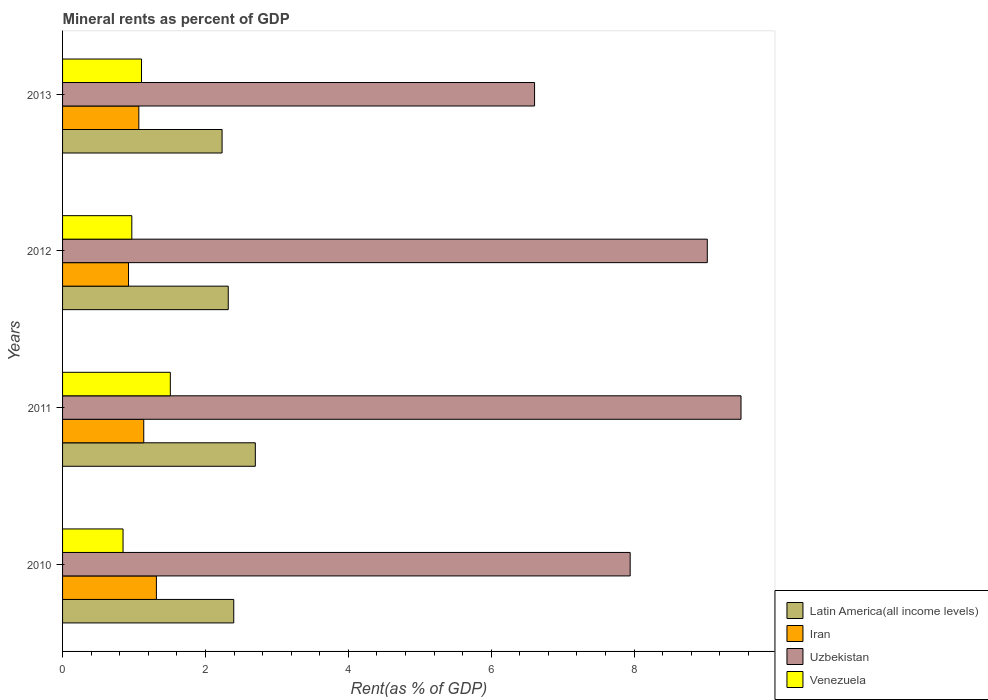In how many cases, is the number of bars for a given year not equal to the number of legend labels?
Provide a short and direct response. 0. What is the mineral rent in Latin America(all income levels) in 2010?
Offer a very short reply. 2.4. Across all years, what is the maximum mineral rent in Latin America(all income levels)?
Provide a short and direct response. 2.7. Across all years, what is the minimum mineral rent in Iran?
Your answer should be very brief. 0.92. In which year was the mineral rent in Uzbekistan maximum?
Your response must be concise. 2011. What is the total mineral rent in Latin America(all income levels) in the graph?
Provide a short and direct response. 9.65. What is the difference between the mineral rent in Uzbekistan in 2011 and that in 2012?
Provide a short and direct response. 0.47. What is the difference between the mineral rent in Iran in 2011 and the mineral rent in Latin America(all income levels) in 2012?
Give a very brief answer. -1.18. What is the average mineral rent in Uzbekistan per year?
Give a very brief answer. 8.27. In the year 2013, what is the difference between the mineral rent in Latin America(all income levels) and mineral rent in Venezuela?
Your answer should be compact. 1.13. What is the ratio of the mineral rent in Uzbekistan in 2010 to that in 2012?
Your answer should be very brief. 0.88. What is the difference between the highest and the second highest mineral rent in Iran?
Offer a very short reply. 0.18. What is the difference between the highest and the lowest mineral rent in Latin America(all income levels)?
Give a very brief answer. 0.47. Is the sum of the mineral rent in Uzbekistan in 2011 and 2013 greater than the maximum mineral rent in Latin America(all income levels) across all years?
Ensure brevity in your answer.  Yes. Is it the case that in every year, the sum of the mineral rent in Venezuela and mineral rent in Iran is greater than the sum of mineral rent in Uzbekistan and mineral rent in Latin America(all income levels)?
Provide a short and direct response. No. What does the 4th bar from the top in 2011 represents?
Your answer should be compact. Latin America(all income levels). What does the 2nd bar from the bottom in 2011 represents?
Offer a very short reply. Iran. How many bars are there?
Your answer should be very brief. 16. Are all the bars in the graph horizontal?
Your response must be concise. Yes. How are the legend labels stacked?
Keep it short and to the point. Vertical. What is the title of the graph?
Give a very brief answer. Mineral rents as percent of GDP. What is the label or title of the X-axis?
Your answer should be compact. Rent(as % of GDP). What is the label or title of the Y-axis?
Ensure brevity in your answer.  Years. What is the Rent(as % of GDP) of Latin America(all income levels) in 2010?
Your response must be concise. 2.4. What is the Rent(as % of GDP) in Iran in 2010?
Your response must be concise. 1.31. What is the Rent(as % of GDP) in Uzbekistan in 2010?
Provide a succinct answer. 7.95. What is the Rent(as % of GDP) of Venezuela in 2010?
Provide a short and direct response. 0.85. What is the Rent(as % of GDP) of Latin America(all income levels) in 2011?
Your response must be concise. 2.7. What is the Rent(as % of GDP) in Iran in 2011?
Provide a short and direct response. 1.14. What is the Rent(as % of GDP) of Uzbekistan in 2011?
Offer a very short reply. 9.5. What is the Rent(as % of GDP) in Venezuela in 2011?
Offer a very short reply. 1.51. What is the Rent(as % of GDP) of Latin America(all income levels) in 2012?
Your answer should be very brief. 2.32. What is the Rent(as % of GDP) of Iran in 2012?
Ensure brevity in your answer.  0.92. What is the Rent(as % of GDP) in Uzbekistan in 2012?
Provide a short and direct response. 9.03. What is the Rent(as % of GDP) of Venezuela in 2012?
Offer a very short reply. 0.97. What is the Rent(as % of GDP) in Latin America(all income levels) in 2013?
Keep it short and to the point. 2.23. What is the Rent(as % of GDP) of Iran in 2013?
Your response must be concise. 1.07. What is the Rent(as % of GDP) of Uzbekistan in 2013?
Your response must be concise. 6.61. What is the Rent(as % of GDP) in Venezuela in 2013?
Your answer should be compact. 1.11. Across all years, what is the maximum Rent(as % of GDP) in Latin America(all income levels)?
Your answer should be very brief. 2.7. Across all years, what is the maximum Rent(as % of GDP) in Iran?
Offer a very short reply. 1.31. Across all years, what is the maximum Rent(as % of GDP) of Uzbekistan?
Offer a very short reply. 9.5. Across all years, what is the maximum Rent(as % of GDP) of Venezuela?
Offer a very short reply. 1.51. Across all years, what is the minimum Rent(as % of GDP) in Latin America(all income levels)?
Your answer should be very brief. 2.23. Across all years, what is the minimum Rent(as % of GDP) in Iran?
Your response must be concise. 0.92. Across all years, what is the minimum Rent(as % of GDP) in Uzbekistan?
Offer a very short reply. 6.61. Across all years, what is the minimum Rent(as % of GDP) of Venezuela?
Your answer should be compact. 0.85. What is the total Rent(as % of GDP) of Latin America(all income levels) in the graph?
Your response must be concise. 9.65. What is the total Rent(as % of GDP) in Iran in the graph?
Offer a very short reply. 4.44. What is the total Rent(as % of GDP) of Uzbekistan in the graph?
Ensure brevity in your answer.  33.08. What is the total Rent(as % of GDP) in Venezuela in the graph?
Offer a very short reply. 4.43. What is the difference between the Rent(as % of GDP) of Latin America(all income levels) in 2010 and that in 2011?
Your answer should be very brief. -0.3. What is the difference between the Rent(as % of GDP) in Iran in 2010 and that in 2011?
Keep it short and to the point. 0.18. What is the difference between the Rent(as % of GDP) in Uzbekistan in 2010 and that in 2011?
Your answer should be compact. -1.55. What is the difference between the Rent(as % of GDP) in Venezuela in 2010 and that in 2011?
Your answer should be very brief. -0.66. What is the difference between the Rent(as % of GDP) of Latin America(all income levels) in 2010 and that in 2012?
Offer a terse response. 0.08. What is the difference between the Rent(as % of GDP) of Iran in 2010 and that in 2012?
Give a very brief answer. 0.39. What is the difference between the Rent(as % of GDP) of Uzbekistan in 2010 and that in 2012?
Your answer should be compact. -1.08. What is the difference between the Rent(as % of GDP) of Venezuela in 2010 and that in 2012?
Keep it short and to the point. -0.12. What is the difference between the Rent(as % of GDP) in Latin America(all income levels) in 2010 and that in 2013?
Keep it short and to the point. 0.16. What is the difference between the Rent(as % of GDP) in Iran in 2010 and that in 2013?
Your answer should be compact. 0.25. What is the difference between the Rent(as % of GDP) in Uzbekistan in 2010 and that in 2013?
Offer a terse response. 1.34. What is the difference between the Rent(as % of GDP) of Venezuela in 2010 and that in 2013?
Give a very brief answer. -0.26. What is the difference between the Rent(as % of GDP) of Latin America(all income levels) in 2011 and that in 2012?
Offer a very short reply. 0.38. What is the difference between the Rent(as % of GDP) of Iran in 2011 and that in 2012?
Provide a succinct answer. 0.21. What is the difference between the Rent(as % of GDP) of Uzbekistan in 2011 and that in 2012?
Offer a terse response. 0.47. What is the difference between the Rent(as % of GDP) in Venezuela in 2011 and that in 2012?
Provide a succinct answer. 0.54. What is the difference between the Rent(as % of GDP) in Latin America(all income levels) in 2011 and that in 2013?
Your answer should be compact. 0.47. What is the difference between the Rent(as % of GDP) of Iran in 2011 and that in 2013?
Your response must be concise. 0.07. What is the difference between the Rent(as % of GDP) in Uzbekistan in 2011 and that in 2013?
Your answer should be very brief. 2.89. What is the difference between the Rent(as % of GDP) in Venezuela in 2011 and that in 2013?
Your answer should be compact. 0.4. What is the difference between the Rent(as % of GDP) of Latin America(all income levels) in 2012 and that in 2013?
Your answer should be very brief. 0.09. What is the difference between the Rent(as % of GDP) of Iran in 2012 and that in 2013?
Offer a very short reply. -0.14. What is the difference between the Rent(as % of GDP) in Uzbekistan in 2012 and that in 2013?
Provide a succinct answer. 2.42. What is the difference between the Rent(as % of GDP) of Venezuela in 2012 and that in 2013?
Offer a terse response. -0.14. What is the difference between the Rent(as % of GDP) of Latin America(all income levels) in 2010 and the Rent(as % of GDP) of Iran in 2011?
Provide a succinct answer. 1.26. What is the difference between the Rent(as % of GDP) of Latin America(all income levels) in 2010 and the Rent(as % of GDP) of Uzbekistan in 2011?
Make the answer very short. -7.1. What is the difference between the Rent(as % of GDP) in Latin America(all income levels) in 2010 and the Rent(as % of GDP) in Venezuela in 2011?
Provide a short and direct response. 0.89. What is the difference between the Rent(as % of GDP) in Iran in 2010 and the Rent(as % of GDP) in Uzbekistan in 2011?
Provide a short and direct response. -8.18. What is the difference between the Rent(as % of GDP) of Iran in 2010 and the Rent(as % of GDP) of Venezuela in 2011?
Keep it short and to the point. -0.19. What is the difference between the Rent(as % of GDP) of Uzbekistan in 2010 and the Rent(as % of GDP) of Venezuela in 2011?
Offer a terse response. 6.44. What is the difference between the Rent(as % of GDP) of Latin America(all income levels) in 2010 and the Rent(as % of GDP) of Iran in 2012?
Your answer should be compact. 1.47. What is the difference between the Rent(as % of GDP) of Latin America(all income levels) in 2010 and the Rent(as % of GDP) of Uzbekistan in 2012?
Your response must be concise. -6.63. What is the difference between the Rent(as % of GDP) of Latin America(all income levels) in 2010 and the Rent(as % of GDP) of Venezuela in 2012?
Your answer should be compact. 1.43. What is the difference between the Rent(as % of GDP) in Iran in 2010 and the Rent(as % of GDP) in Uzbekistan in 2012?
Make the answer very short. -7.71. What is the difference between the Rent(as % of GDP) of Iran in 2010 and the Rent(as % of GDP) of Venezuela in 2012?
Offer a terse response. 0.34. What is the difference between the Rent(as % of GDP) in Uzbekistan in 2010 and the Rent(as % of GDP) in Venezuela in 2012?
Offer a terse response. 6.98. What is the difference between the Rent(as % of GDP) of Latin America(all income levels) in 2010 and the Rent(as % of GDP) of Iran in 2013?
Offer a terse response. 1.33. What is the difference between the Rent(as % of GDP) in Latin America(all income levels) in 2010 and the Rent(as % of GDP) in Uzbekistan in 2013?
Provide a short and direct response. -4.21. What is the difference between the Rent(as % of GDP) in Latin America(all income levels) in 2010 and the Rent(as % of GDP) in Venezuela in 2013?
Offer a very short reply. 1.29. What is the difference between the Rent(as % of GDP) of Iran in 2010 and the Rent(as % of GDP) of Uzbekistan in 2013?
Make the answer very short. -5.29. What is the difference between the Rent(as % of GDP) in Iran in 2010 and the Rent(as % of GDP) in Venezuela in 2013?
Make the answer very short. 0.21. What is the difference between the Rent(as % of GDP) of Uzbekistan in 2010 and the Rent(as % of GDP) of Venezuela in 2013?
Provide a succinct answer. 6.84. What is the difference between the Rent(as % of GDP) of Latin America(all income levels) in 2011 and the Rent(as % of GDP) of Iran in 2012?
Ensure brevity in your answer.  1.77. What is the difference between the Rent(as % of GDP) of Latin America(all income levels) in 2011 and the Rent(as % of GDP) of Uzbekistan in 2012?
Give a very brief answer. -6.33. What is the difference between the Rent(as % of GDP) of Latin America(all income levels) in 2011 and the Rent(as % of GDP) of Venezuela in 2012?
Keep it short and to the point. 1.73. What is the difference between the Rent(as % of GDP) of Iran in 2011 and the Rent(as % of GDP) of Uzbekistan in 2012?
Your answer should be very brief. -7.89. What is the difference between the Rent(as % of GDP) of Iran in 2011 and the Rent(as % of GDP) of Venezuela in 2012?
Make the answer very short. 0.17. What is the difference between the Rent(as % of GDP) in Uzbekistan in 2011 and the Rent(as % of GDP) in Venezuela in 2012?
Your response must be concise. 8.53. What is the difference between the Rent(as % of GDP) in Latin America(all income levels) in 2011 and the Rent(as % of GDP) in Iran in 2013?
Provide a succinct answer. 1.63. What is the difference between the Rent(as % of GDP) in Latin America(all income levels) in 2011 and the Rent(as % of GDP) in Uzbekistan in 2013?
Provide a short and direct response. -3.91. What is the difference between the Rent(as % of GDP) in Latin America(all income levels) in 2011 and the Rent(as % of GDP) in Venezuela in 2013?
Your answer should be compact. 1.59. What is the difference between the Rent(as % of GDP) in Iran in 2011 and the Rent(as % of GDP) in Uzbekistan in 2013?
Your response must be concise. -5.47. What is the difference between the Rent(as % of GDP) of Iran in 2011 and the Rent(as % of GDP) of Venezuela in 2013?
Your answer should be compact. 0.03. What is the difference between the Rent(as % of GDP) of Uzbekistan in 2011 and the Rent(as % of GDP) of Venezuela in 2013?
Provide a short and direct response. 8.39. What is the difference between the Rent(as % of GDP) of Latin America(all income levels) in 2012 and the Rent(as % of GDP) of Iran in 2013?
Offer a very short reply. 1.25. What is the difference between the Rent(as % of GDP) in Latin America(all income levels) in 2012 and the Rent(as % of GDP) in Uzbekistan in 2013?
Provide a short and direct response. -4.29. What is the difference between the Rent(as % of GDP) of Latin America(all income levels) in 2012 and the Rent(as % of GDP) of Venezuela in 2013?
Provide a short and direct response. 1.21. What is the difference between the Rent(as % of GDP) of Iran in 2012 and the Rent(as % of GDP) of Uzbekistan in 2013?
Your response must be concise. -5.68. What is the difference between the Rent(as % of GDP) in Iran in 2012 and the Rent(as % of GDP) in Venezuela in 2013?
Your response must be concise. -0.18. What is the difference between the Rent(as % of GDP) in Uzbekistan in 2012 and the Rent(as % of GDP) in Venezuela in 2013?
Your answer should be compact. 7.92. What is the average Rent(as % of GDP) in Latin America(all income levels) per year?
Make the answer very short. 2.41. What is the average Rent(as % of GDP) in Iran per year?
Provide a succinct answer. 1.11. What is the average Rent(as % of GDP) of Uzbekistan per year?
Offer a terse response. 8.27. What is the average Rent(as % of GDP) in Venezuela per year?
Keep it short and to the point. 1.11. In the year 2010, what is the difference between the Rent(as % of GDP) of Latin America(all income levels) and Rent(as % of GDP) of Iran?
Make the answer very short. 1.08. In the year 2010, what is the difference between the Rent(as % of GDP) of Latin America(all income levels) and Rent(as % of GDP) of Uzbekistan?
Keep it short and to the point. -5.55. In the year 2010, what is the difference between the Rent(as % of GDP) in Latin America(all income levels) and Rent(as % of GDP) in Venezuela?
Keep it short and to the point. 1.55. In the year 2010, what is the difference between the Rent(as % of GDP) in Iran and Rent(as % of GDP) in Uzbekistan?
Make the answer very short. -6.63. In the year 2010, what is the difference between the Rent(as % of GDP) of Iran and Rent(as % of GDP) of Venezuela?
Your answer should be compact. 0.47. In the year 2010, what is the difference between the Rent(as % of GDP) in Uzbekistan and Rent(as % of GDP) in Venezuela?
Your response must be concise. 7.1. In the year 2011, what is the difference between the Rent(as % of GDP) in Latin America(all income levels) and Rent(as % of GDP) in Iran?
Offer a very short reply. 1.56. In the year 2011, what is the difference between the Rent(as % of GDP) of Latin America(all income levels) and Rent(as % of GDP) of Uzbekistan?
Give a very brief answer. -6.8. In the year 2011, what is the difference between the Rent(as % of GDP) of Latin America(all income levels) and Rent(as % of GDP) of Venezuela?
Make the answer very short. 1.19. In the year 2011, what is the difference between the Rent(as % of GDP) of Iran and Rent(as % of GDP) of Uzbekistan?
Provide a short and direct response. -8.36. In the year 2011, what is the difference between the Rent(as % of GDP) in Iran and Rent(as % of GDP) in Venezuela?
Offer a terse response. -0.37. In the year 2011, what is the difference between the Rent(as % of GDP) of Uzbekistan and Rent(as % of GDP) of Venezuela?
Give a very brief answer. 7.99. In the year 2012, what is the difference between the Rent(as % of GDP) of Latin America(all income levels) and Rent(as % of GDP) of Iran?
Offer a terse response. 1.4. In the year 2012, what is the difference between the Rent(as % of GDP) in Latin America(all income levels) and Rent(as % of GDP) in Uzbekistan?
Make the answer very short. -6.71. In the year 2012, what is the difference between the Rent(as % of GDP) of Latin America(all income levels) and Rent(as % of GDP) of Venezuela?
Your answer should be very brief. 1.35. In the year 2012, what is the difference between the Rent(as % of GDP) in Iran and Rent(as % of GDP) in Uzbekistan?
Give a very brief answer. -8.1. In the year 2012, what is the difference between the Rent(as % of GDP) of Iran and Rent(as % of GDP) of Venezuela?
Give a very brief answer. -0.05. In the year 2012, what is the difference between the Rent(as % of GDP) of Uzbekistan and Rent(as % of GDP) of Venezuela?
Make the answer very short. 8.06. In the year 2013, what is the difference between the Rent(as % of GDP) of Latin America(all income levels) and Rent(as % of GDP) of Iran?
Your answer should be compact. 1.17. In the year 2013, what is the difference between the Rent(as % of GDP) in Latin America(all income levels) and Rent(as % of GDP) in Uzbekistan?
Your answer should be very brief. -4.37. In the year 2013, what is the difference between the Rent(as % of GDP) of Latin America(all income levels) and Rent(as % of GDP) of Venezuela?
Your response must be concise. 1.13. In the year 2013, what is the difference between the Rent(as % of GDP) in Iran and Rent(as % of GDP) in Uzbekistan?
Your answer should be compact. -5.54. In the year 2013, what is the difference between the Rent(as % of GDP) of Iran and Rent(as % of GDP) of Venezuela?
Offer a terse response. -0.04. In the year 2013, what is the difference between the Rent(as % of GDP) of Uzbekistan and Rent(as % of GDP) of Venezuela?
Make the answer very short. 5.5. What is the ratio of the Rent(as % of GDP) of Latin America(all income levels) in 2010 to that in 2011?
Provide a succinct answer. 0.89. What is the ratio of the Rent(as % of GDP) of Iran in 2010 to that in 2011?
Offer a very short reply. 1.16. What is the ratio of the Rent(as % of GDP) in Uzbekistan in 2010 to that in 2011?
Your answer should be compact. 0.84. What is the ratio of the Rent(as % of GDP) in Venezuela in 2010 to that in 2011?
Offer a terse response. 0.56. What is the ratio of the Rent(as % of GDP) of Latin America(all income levels) in 2010 to that in 2012?
Offer a very short reply. 1.03. What is the ratio of the Rent(as % of GDP) in Iran in 2010 to that in 2012?
Your answer should be very brief. 1.42. What is the ratio of the Rent(as % of GDP) in Uzbekistan in 2010 to that in 2012?
Your response must be concise. 0.88. What is the ratio of the Rent(as % of GDP) of Venezuela in 2010 to that in 2012?
Provide a short and direct response. 0.87. What is the ratio of the Rent(as % of GDP) of Latin America(all income levels) in 2010 to that in 2013?
Your answer should be compact. 1.07. What is the ratio of the Rent(as % of GDP) in Iran in 2010 to that in 2013?
Provide a succinct answer. 1.23. What is the ratio of the Rent(as % of GDP) of Uzbekistan in 2010 to that in 2013?
Your answer should be compact. 1.2. What is the ratio of the Rent(as % of GDP) in Venezuela in 2010 to that in 2013?
Provide a short and direct response. 0.77. What is the ratio of the Rent(as % of GDP) in Latin America(all income levels) in 2011 to that in 2012?
Your response must be concise. 1.16. What is the ratio of the Rent(as % of GDP) in Iran in 2011 to that in 2012?
Ensure brevity in your answer.  1.23. What is the ratio of the Rent(as % of GDP) of Uzbekistan in 2011 to that in 2012?
Make the answer very short. 1.05. What is the ratio of the Rent(as % of GDP) in Venezuela in 2011 to that in 2012?
Ensure brevity in your answer.  1.56. What is the ratio of the Rent(as % of GDP) in Latin America(all income levels) in 2011 to that in 2013?
Give a very brief answer. 1.21. What is the ratio of the Rent(as % of GDP) of Iran in 2011 to that in 2013?
Your answer should be compact. 1.06. What is the ratio of the Rent(as % of GDP) in Uzbekistan in 2011 to that in 2013?
Offer a terse response. 1.44. What is the ratio of the Rent(as % of GDP) in Venezuela in 2011 to that in 2013?
Your response must be concise. 1.36. What is the ratio of the Rent(as % of GDP) of Latin America(all income levels) in 2012 to that in 2013?
Provide a short and direct response. 1.04. What is the ratio of the Rent(as % of GDP) of Iran in 2012 to that in 2013?
Your answer should be compact. 0.86. What is the ratio of the Rent(as % of GDP) of Uzbekistan in 2012 to that in 2013?
Your response must be concise. 1.37. What is the ratio of the Rent(as % of GDP) in Venezuela in 2012 to that in 2013?
Your response must be concise. 0.88. What is the difference between the highest and the second highest Rent(as % of GDP) of Latin America(all income levels)?
Offer a very short reply. 0.3. What is the difference between the highest and the second highest Rent(as % of GDP) in Iran?
Your response must be concise. 0.18. What is the difference between the highest and the second highest Rent(as % of GDP) of Uzbekistan?
Provide a short and direct response. 0.47. What is the difference between the highest and the second highest Rent(as % of GDP) in Venezuela?
Offer a very short reply. 0.4. What is the difference between the highest and the lowest Rent(as % of GDP) of Latin America(all income levels)?
Your answer should be very brief. 0.47. What is the difference between the highest and the lowest Rent(as % of GDP) in Iran?
Your answer should be compact. 0.39. What is the difference between the highest and the lowest Rent(as % of GDP) of Uzbekistan?
Provide a short and direct response. 2.89. What is the difference between the highest and the lowest Rent(as % of GDP) in Venezuela?
Keep it short and to the point. 0.66. 